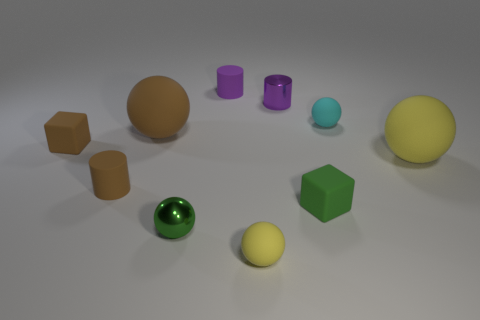Subtract all yellow cylinders. How many yellow balls are left? 2 Subtract all cyan balls. How many balls are left? 4 Subtract all cyan spheres. How many spheres are left? 4 Subtract all red spheres. Subtract all cyan cubes. How many spheres are left? 5 Subtract all tiny brown rubber cylinders. Subtract all purple matte things. How many objects are left? 8 Add 3 small yellow things. How many small yellow things are left? 4 Add 7 purple metal blocks. How many purple metal blocks exist? 7 Subtract 0 blue spheres. How many objects are left? 10 Subtract all cubes. How many objects are left? 8 